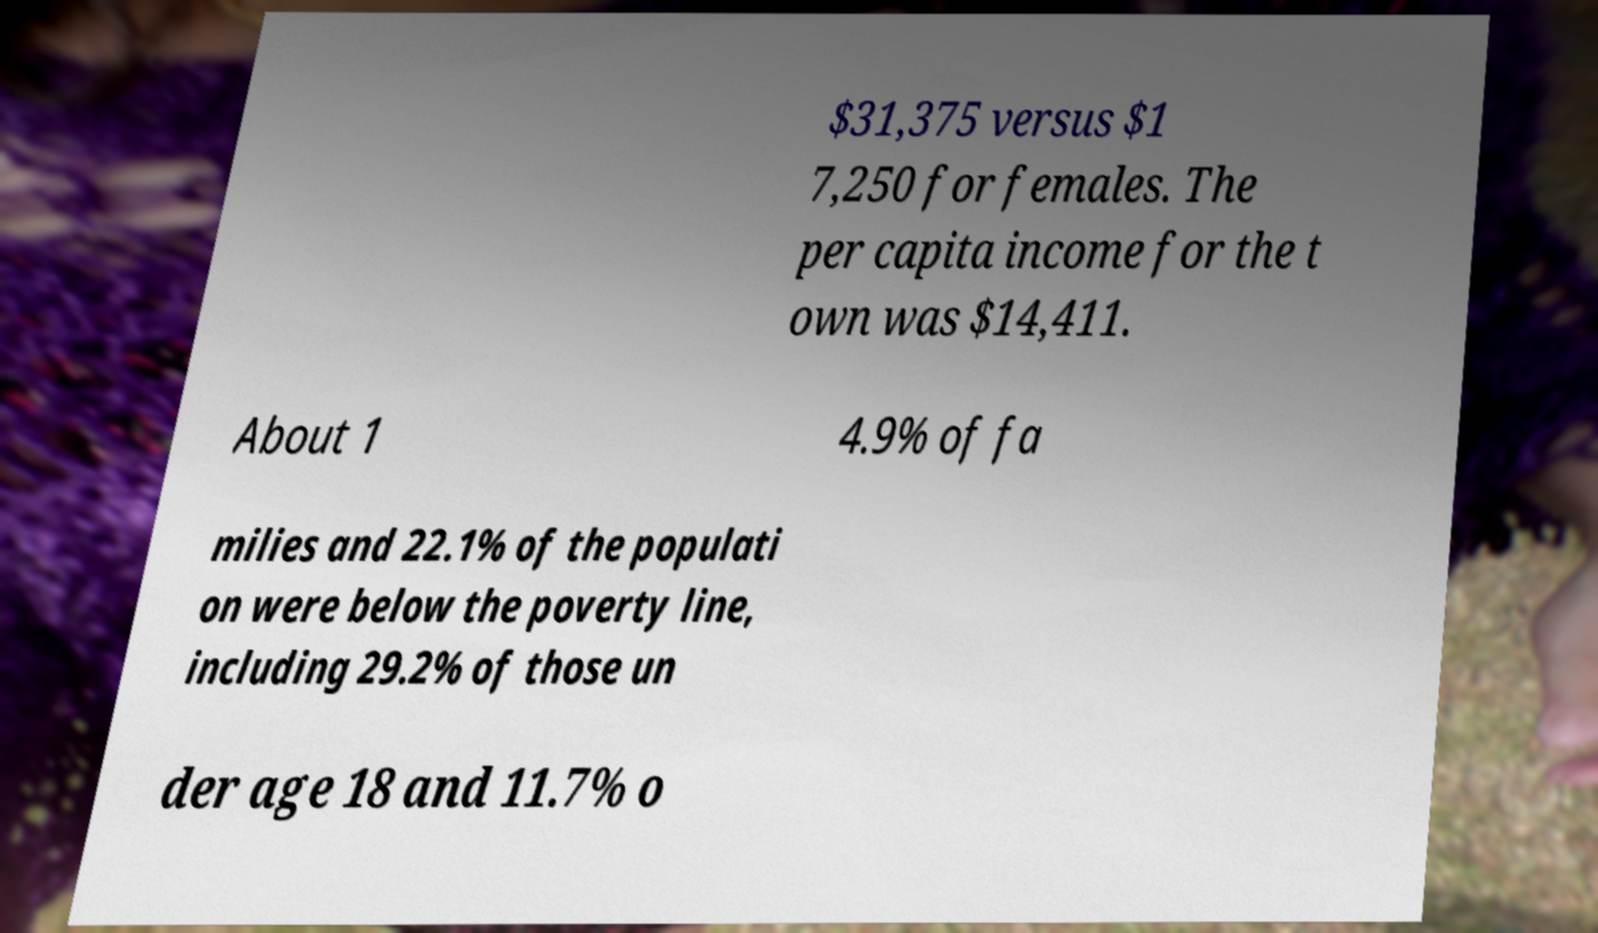For documentation purposes, I need the text within this image transcribed. Could you provide that? $31,375 versus $1 7,250 for females. The per capita income for the t own was $14,411. About 1 4.9% of fa milies and 22.1% of the populati on were below the poverty line, including 29.2% of those un der age 18 and 11.7% o 